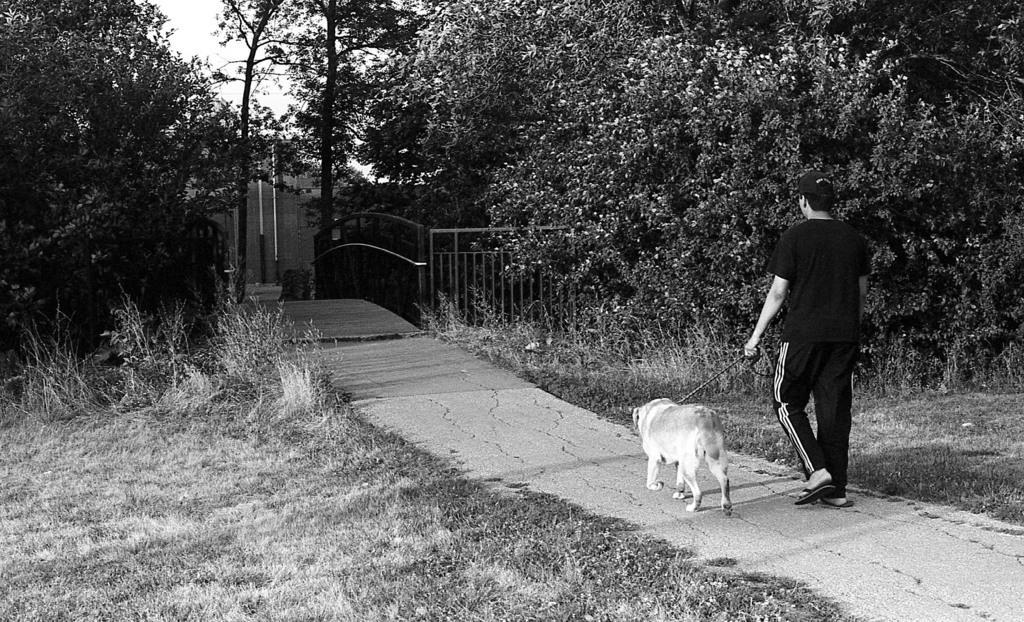In one or two sentences, can you explain what this image depicts? This picture shows a man walking and holding a dog with a string and we see trees around and a metal fence he wore a cap on his head 